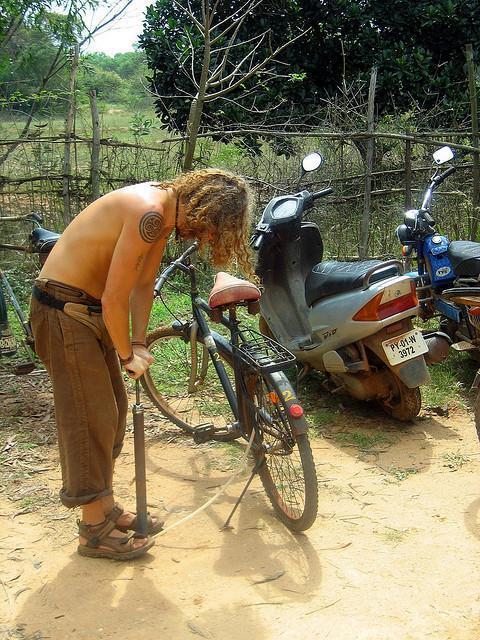How many bicycles are there?
Give a very brief answer. 2. How many motorcycles are there?
Give a very brief answer. 2. How many elephants are in the photo?
Give a very brief answer. 0. 